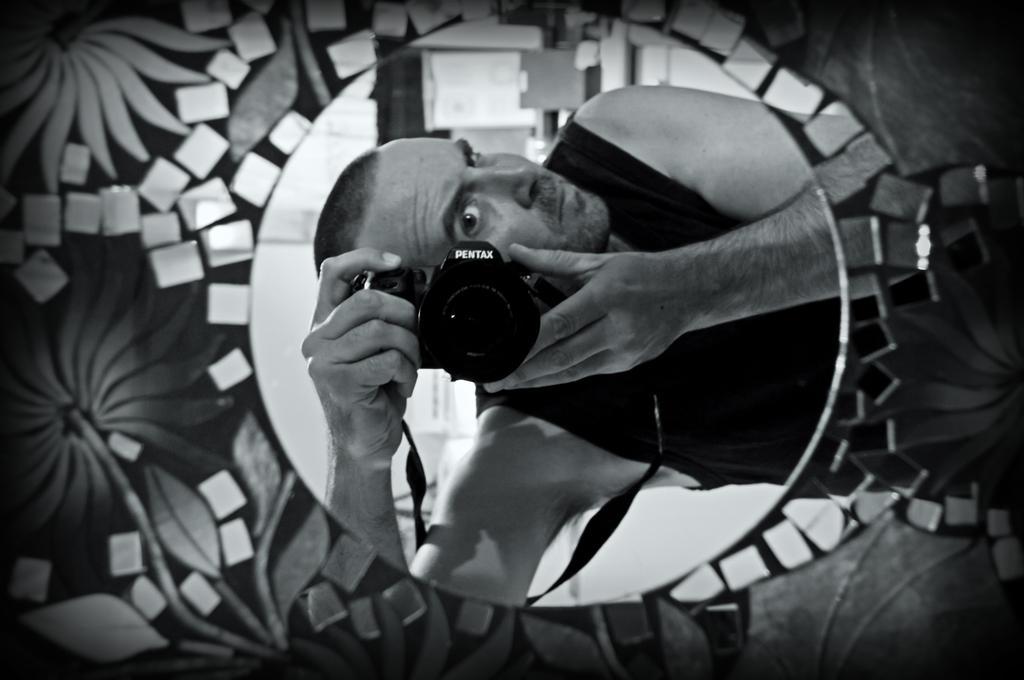How would you summarize this image in a sentence or two? This is a black and white image. In the foreground, I can see a design board. At the back of it there is a man holding a camera in the hands. 